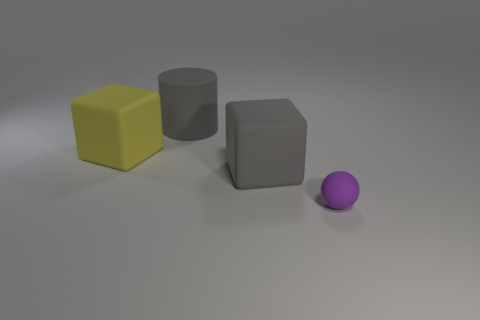Is there any other thing that is the same size as the sphere?
Ensure brevity in your answer.  No. There is a rubber cylinder behind the yellow rubber cube; is its color the same as the rubber thing to the right of the large gray matte block?
Provide a succinct answer. No. How many rubber objects are either big purple cylinders or purple balls?
Offer a very short reply. 1. What shape is the big thing that is behind the large matte cube left of the gray cylinder?
Offer a very short reply. Cylinder. Does the tiny thing on the right side of the large gray matte cylinder have the same material as the cube that is on the left side of the large gray block?
Keep it short and to the point. Yes. There is a large gray object that is in front of the gray cylinder; how many big matte things are behind it?
Provide a short and direct response. 2. Does the big gray thing to the left of the large gray block have the same shape as the large rubber thing that is left of the large gray rubber cylinder?
Your answer should be compact. No. There is a matte thing that is both behind the gray rubber block and right of the big yellow matte thing; what size is it?
Provide a succinct answer. Large. What is the color of the other object that is the same shape as the large yellow object?
Your response must be concise. Gray. There is a object that is to the left of the gray object behind the yellow rubber block; what color is it?
Keep it short and to the point. Yellow. 